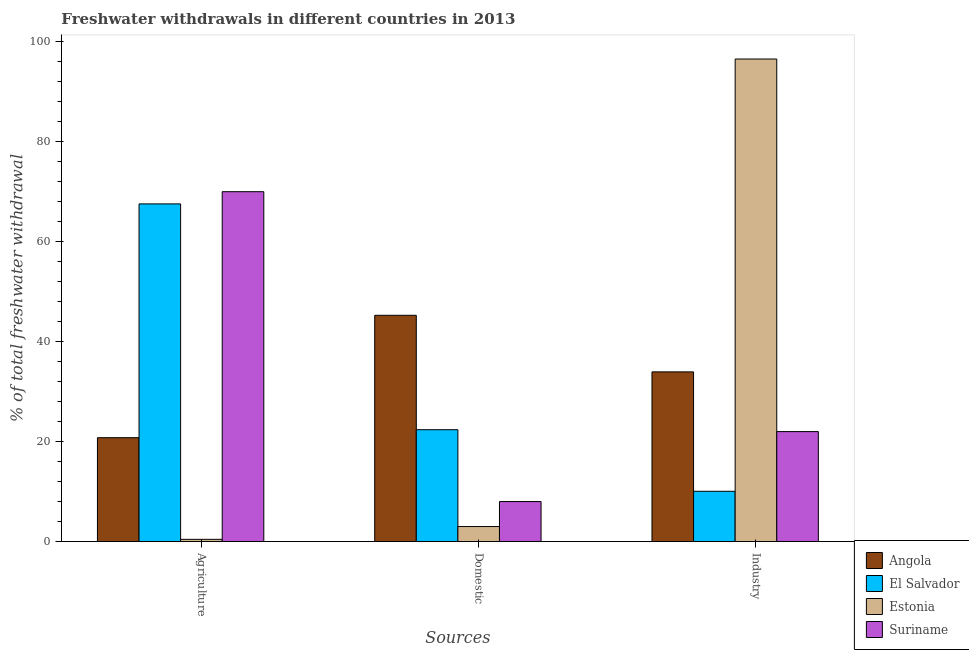How many groups of bars are there?
Provide a short and direct response. 3. Are the number of bars on each tick of the X-axis equal?
Offer a terse response. Yes. How many bars are there on the 2nd tick from the right?
Ensure brevity in your answer.  4. What is the label of the 1st group of bars from the left?
Ensure brevity in your answer.  Agriculture. What is the percentage of freshwater withdrawal for agriculture in El Salvador?
Your answer should be very brief. 67.56. Across all countries, what is the maximum percentage of freshwater withdrawal for industry?
Make the answer very short. 96.55. Across all countries, what is the minimum percentage of freshwater withdrawal for domestic purposes?
Offer a very short reply. 3.01. In which country was the percentage of freshwater withdrawal for domestic purposes maximum?
Keep it short and to the point. Angola. In which country was the percentage of freshwater withdrawal for industry minimum?
Your response must be concise. El Salvador. What is the total percentage of freshwater withdrawal for domestic purposes in the graph?
Offer a very short reply. 78.66. What is the difference between the percentage of freshwater withdrawal for domestic purposes in Estonia and that in Suriname?
Your answer should be very brief. -5. What is the difference between the percentage of freshwater withdrawal for domestic purposes in Angola and the percentage of freshwater withdrawal for industry in Estonia?
Offer a very short reply. -51.28. What is the average percentage of freshwater withdrawal for industry per country?
Your response must be concise. 40.64. What is the difference between the percentage of freshwater withdrawal for domestic purposes and percentage of freshwater withdrawal for agriculture in Estonia?
Your answer should be very brief. 2.56. In how many countries, is the percentage of freshwater withdrawal for industry greater than 52 %?
Offer a very short reply. 1. What is the ratio of the percentage of freshwater withdrawal for agriculture in Angola to that in El Salvador?
Offer a terse response. 0.31. Is the difference between the percentage of freshwater withdrawal for domestic purposes in Angola and El Salvador greater than the difference between the percentage of freshwater withdrawal for industry in Angola and El Salvador?
Offer a terse response. No. What is the difference between the highest and the second highest percentage of freshwater withdrawal for industry?
Make the answer very short. 62.6. What is the difference between the highest and the lowest percentage of freshwater withdrawal for agriculture?
Your answer should be compact. 69.55. What does the 2nd bar from the left in Domestic represents?
Your answer should be very brief. El Salvador. What does the 1st bar from the right in Agriculture represents?
Offer a very short reply. Suriname. Is it the case that in every country, the sum of the percentage of freshwater withdrawal for agriculture and percentage of freshwater withdrawal for domestic purposes is greater than the percentage of freshwater withdrawal for industry?
Make the answer very short. No. How many countries are there in the graph?
Keep it short and to the point. 4. Does the graph contain any zero values?
Make the answer very short. No. Does the graph contain grids?
Ensure brevity in your answer.  No. Where does the legend appear in the graph?
Your answer should be compact. Bottom right. What is the title of the graph?
Your answer should be very brief. Freshwater withdrawals in different countries in 2013. Does "Senegal" appear as one of the legend labels in the graph?
Provide a short and direct response. No. What is the label or title of the X-axis?
Provide a succinct answer. Sources. What is the label or title of the Y-axis?
Keep it short and to the point. % of total freshwater withdrawal. What is the % of total freshwater withdrawal in Angola in Agriculture?
Offer a very short reply. 20.78. What is the % of total freshwater withdrawal in El Salvador in Agriculture?
Your answer should be compact. 67.56. What is the % of total freshwater withdrawal of Estonia in Agriculture?
Make the answer very short. 0.45. What is the % of total freshwater withdrawal in Angola in Domestic?
Offer a very short reply. 45.27. What is the % of total freshwater withdrawal of El Salvador in Domestic?
Ensure brevity in your answer.  22.38. What is the % of total freshwater withdrawal of Estonia in Domestic?
Provide a short and direct response. 3.01. What is the % of total freshwater withdrawal in Suriname in Domestic?
Offer a terse response. 8.01. What is the % of total freshwater withdrawal of Angola in Industry?
Provide a short and direct response. 33.95. What is the % of total freshwater withdrawal in El Salvador in Industry?
Your response must be concise. 10.06. What is the % of total freshwater withdrawal of Estonia in Industry?
Your answer should be very brief. 96.55. What is the % of total freshwater withdrawal in Suriname in Industry?
Keep it short and to the point. 22. Across all Sources, what is the maximum % of total freshwater withdrawal in Angola?
Offer a terse response. 45.27. Across all Sources, what is the maximum % of total freshwater withdrawal of El Salvador?
Give a very brief answer. 67.56. Across all Sources, what is the maximum % of total freshwater withdrawal of Estonia?
Keep it short and to the point. 96.55. Across all Sources, what is the minimum % of total freshwater withdrawal in Angola?
Provide a succinct answer. 20.78. Across all Sources, what is the minimum % of total freshwater withdrawal in El Salvador?
Your response must be concise. 10.06. Across all Sources, what is the minimum % of total freshwater withdrawal in Estonia?
Provide a short and direct response. 0.45. Across all Sources, what is the minimum % of total freshwater withdrawal in Suriname?
Provide a succinct answer. 8.01. What is the total % of total freshwater withdrawal in Angola in the graph?
Your answer should be very brief. 100. What is the total % of total freshwater withdrawal of El Salvador in the graph?
Provide a succinct answer. 100. What is the total % of total freshwater withdrawal of Estonia in the graph?
Your answer should be very brief. 100. What is the total % of total freshwater withdrawal in Suriname in the graph?
Keep it short and to the point. 100. What is the difference between the % of total freshwater withdrawal in Angola in Agriculture and that in Domestic?
Keep it short and to the point. -24.49. What is the difference between the % of total freshwater withdrawal in El Salvador in Agriculture and that in Domestic?
Make the answer very short. 45.18. What is the difference between the % of total freshwater withdrawal in Estonia in Agriculture and that in Domestic?
Your response must be concise. -2.56. What is the difference between the % of total freshwater withdrawal in Suriname in Agriculture and that in Domestic?
Offer a very short reply. 61.99. What is the difference between the % of total freshwater withdrawal in Angola in Agriculture and that in Industry?
Ensure brevity in your answer.  -13.17. What is the difference between the % of total freshwater withdrawal in El Salvador in Agriculture and that in Industry?
Ensure brevity in your answer.  57.5. What is the difference between the % of total freshwater withdrawal in Estonia in Agriculture and that in Industry?
Make the answer very short. -96.1. What is the difference between the % of total freshwater withdrawal in Suriname in Agriculture and that in Industry?
Ensure brevity in your answer.  48. What is the difference between the % of total freshwater withdrawal in Angola in Domestic and that in Industry?
Provide a succinct answer. 11.32. What is the difference between the % of total freshwater withdrawal in El Salvador in Domestic and that in Industry?
Offer a terse response. 12.32. What is the difference between the % of total freshwater withdrawal in Estonia in Domestic and that in Industry?
Keep it short and to the point. -93.54. What is the difference between the % of total freshwater withdrawal of Suriname in Domestic and that in Industry?
Give a very brief answer. -13.99. What is the difference between the % of total freshwater withdrawal of Angola in Agriculture and the % of total freshwater withdrawal of Estonia in Domestic?
Provide a succinct answer. 17.77. What is the difference between the % of total freshwater withdrawal of Angola in Agriculture and the % of total freshwater withdrawal of Suriname in Domestic?
Your answer should be compact. 12.78. What is the difference between the % of total freshwater withdrawal of El Salvador in Agriculture and the % of total freshwater withdrawal of Estonia in Domestic?
Offer a terse response. 64.55. What is the difference between the % of total freshwater withdrawal in El Salvador in Agriculture and the % of total freshwater withdrawal in Suriname in Domestic?
Offer a very short reply. 59.55. What is the difference between the % of total freshwater withdrawal in Estonia in Agriculture and the % of total freshwater withdrawal in Suriname in Domestic?
Your response must be concise. -7.56. What is the difference between the % of total freshwater withdrawal of Angola in Agriculture and the % of total freshwater withdrawal of El Salvador in Industry?
Your answer should be compact. 10.72. What is the difference between the % of total freshwater withdrawal in Angola in Agriculture and the % of total freshwater withdrawal in Estonia in Industry?
Ensure brevity in your answer.  -75.77. What is the difference between the % of total freshwater withdrawal in Angola in Agriculture and the % of total freshwater withdrawal in Suriname in Industry?
Ensure brevity in your answer.  -1.22. What is the difference between the % of total freshwater withdrawal in El Salvador in Agriculture and the % of total freshwater withdrawal in Estonia in Industry?
Ensure brevity in your answer.  -28.99. What is the difference between the % of total freshwater withdrawal of El Salvador in Agriculture and the % of total freshwater withdrawal of Suriname in Industry?
Provide a short and direct response. 45.56. What is the difference between the % of total freshwater withdrawal in Estonia in Agriculture and the % of total freshwater withdrawal in Suriname in Industry?
Offer a terse response. -21.55. What is the difference between the % of total freshwater withdrawal in Angola in Domestic and the % of total freshwater withdrawal in El Salvador in Industry?
Your answer should be very brief. 35.21. What is the difference between the % of total freshwater withdrawal in Angola in Domestic and the % of total freshwater withdrawal in Estonia in Industry?
Offer a terse response. -51.28. What is the difference between the % of total freshwater withdrawal in Angola in Domestic and the % of total freshwater withdrawal in Suriname in Industry?
Make the answer very short. 23.27. What is the difference between the % of total freshwater withdrawal in El Salvador in Domestic and the % of total freshwater withdrawal in Estonia in Industry?
Your response must be concise. -74.17. What is the difference between the % of total freshwater withdrawal of El Salvador in Domestic and the % of total freshwater withdrawal of Suriname in Industry?
Your answer should be compact. 0.38. What is the difference between the % of total freshwater withdrawal in Estonia in Domestic and the % of total freshwater withdrawal in Suriname in Industry?
Ensure brevity in your answer.  -18.99. What is the average % of total freshwater withdrawal of Angola per Sources?
Ensure brevity in your answer.  33.33. What is the average % of total freshwater withdrawal of El Salvador per Sources?
Your answer should be very brief. 33.33. What is the average % of total freshwater withdrawal of Estonia per Sources?
Your response must be concise. 33.33. What is the average % of total freshwater withdrawal in Suriname per Sources?
Your answer should be very brief. 33.34. What is the difference between the % of total freshwater withdrawal of Angola and % of total freshwater withdrawal of El Salvador in Agriculture?
Ensure brevity in your answer.  -46.78. What is the difference between the % of total freshwater withdrawal in Angola and % of total freshwater withdrawal in Estonia in Agriculture?
Make the answer very short. 20.33. What is the difference between the % of total freshwater withdrawal in Angola and % of total freshwater withdrawal in Suriname in Agriculture?
Ensure brevity in your answer.  -49.22. What is the difference between the % of total freshwater withdrawal in El Salvador and % of total freshwater withdrawal in Estonia in Agriculture?
Your answer should be compact. 67.11. What is the difference between the % of total freshwater withdrawal in El Salvador and % of total freshwater withdrawal in Suriname in Agriculture?
Keep it short and to the point. -2.44. What is the difference between the % of total freshwater withdrawal of Estonia and % of total freshwater withdrawal of Suriname in Agriculture?
Provide a succinct answer. -69.55. What is the difference between the % of total freshwater withdrawal of Angola and % of total freshwater withdrawal of El Salvador in Domestic?
Offer a terse response. 22.89. What is the difference between the % of total freshwater withdrawal in Angola and % of total freshwater withdrawal in Estonia in Domestic?
Your answer should be compact. 42.26. What is the difference between the % of total freshwater withdrawal in Angola and % of total freshwater withdrawal in Suriname in Domestic?
Your response must be concise. 37.27. What is the difference between the % of total freshwater withdrawal of El Salvador and % of total freshwater withdrawal of Estonia in Domestic?
Make the answer very short. 19.37. What is the difference between the % of total freshwater withdrawal of El Salvador and % of total freshwater withdrawal of Suriname in Domestic?
Your answer should be compact. 14.38. What is the difference between the % of total freshwater withdrawal of Estonia and % of total freshwater withdrawal of Suriname in Domestic?
Your answer should be very brief. -5. What is the difference between the % of total freshwater withdrawal in Angola and % of total freshwater withdrawal in El Salvador in Industry?
Provide a succinct answer. 23.89. What is the difference between the % of total freshwater withdrawal in Angola and % of total freshwater withdrawal in Estonia in Industry?
Ensure brevity in your answer.  -62.6. What is the difference between the % of total freshwater withdrawal in Angola and % of total freshwater withdrawal in Suriname in Industry?
Your answer should be very brief. 11.95. What is the difference between the % of total freshwater withdrawal of El Salvador and % of total freshwater withdrawal of Estonia in Industry?
Give a very brief answer. -86.49. What is the difference between the % of total freshwater withdrawal of El Salvador and % of total freshwater withdrawal of Suriname in Industry?
Provide a short and direct response. -11.94. What is the difference between the % of total freshwater withdrawal of Estonia and % of total freshwater withdrawal of Suriname in Industry?
Provide a succinct answer. 74.55. What is the ratio of the % of total freshwater withdrawal of Angola in Agriculture to that in Domestic?
Offer a very short reply. 0.46. What is the ratio of the % of total freshwater withdrawal in El Salvador in Agriculture to that in Domestic?
Your answer should be very brief. 3.02. What is the ratio of the % of total freshwater withdrawal in Estonia in Agriculture to that in Domestic?
Your answer should be compact. 0.15. What is the ratio of the % of total freshwater withdrawal of Suriname in Agriculture to that in Domestic?
Your answer should be compact. 8.74. What is the ratio of the % of total freshwater withdrawal of Angola in Agriculture to that in Industry?
Give a very brief answer. 0.61. What is the ratio of the % of total freshwater withdrawal of El Salvador in Agriculture to that in Industry?
Your response must be concise. 6.72. What is the ratio of the % of total freshwater withdrawal in Estonia in Agriculture to that in Industry?
Your response must be concise. 0. What is the ratio of the % of total freshwater withdrawal of Suriname in Agriculture to that in Industry?
Ensure brevity in your answer.  3.18. What is the ratio of the % of total freshwater withdrawal in Angola in Domestic to that in Industry?
Make the answer very short. 1.33. What is the ratio of the % of total freshwater withdrawal in El Salvador in Domestic to that in Industry?
Offer a terse response. 2.22. What is the ratio of the % of total freshwater withdrawal in Estonia in Domestic to that in Industry?
Offer a terse response. 0.03. What is the ratio of the % of total freshwater withdrawal in Suriname in Domestic to that in Industry?
Provide a succinct answer. 0.36. What is the difference between the highest and the second highest % of total freshwater withdrawal in Angola?
Make the answer very short. 11.32. What is the difference between the highest and the second highest % of total freshwater withdrawal of El Salvador?
Your answer should be very brief. 45.18. What is the difference between the highest and the second highest % of total freshwater withdrawal in Estonia?
Give a very brief answer. 93.54. What is the difference between the highest and the second highest % of total freshwater withdrawal of Suriname?
Provide a succinct answer. 48. What is the difference between the highest and the lowest % of total freshwater withdrawal of Angola?
Provide a short and direct response. 24.49. What is the difference between the highest and the lowest % of total freshwater withdrawal of El Salvador?
Make the answer very short. 57.5. What is the difference between the highest and the lowest % of total freshwater withdrawal in Estonia?
Provide a succinct answer. 96.1. What is the difference between the highest and the lowest % of total freshwater withdrawal in Suriname?
Give a very brief answer. 61.99. 